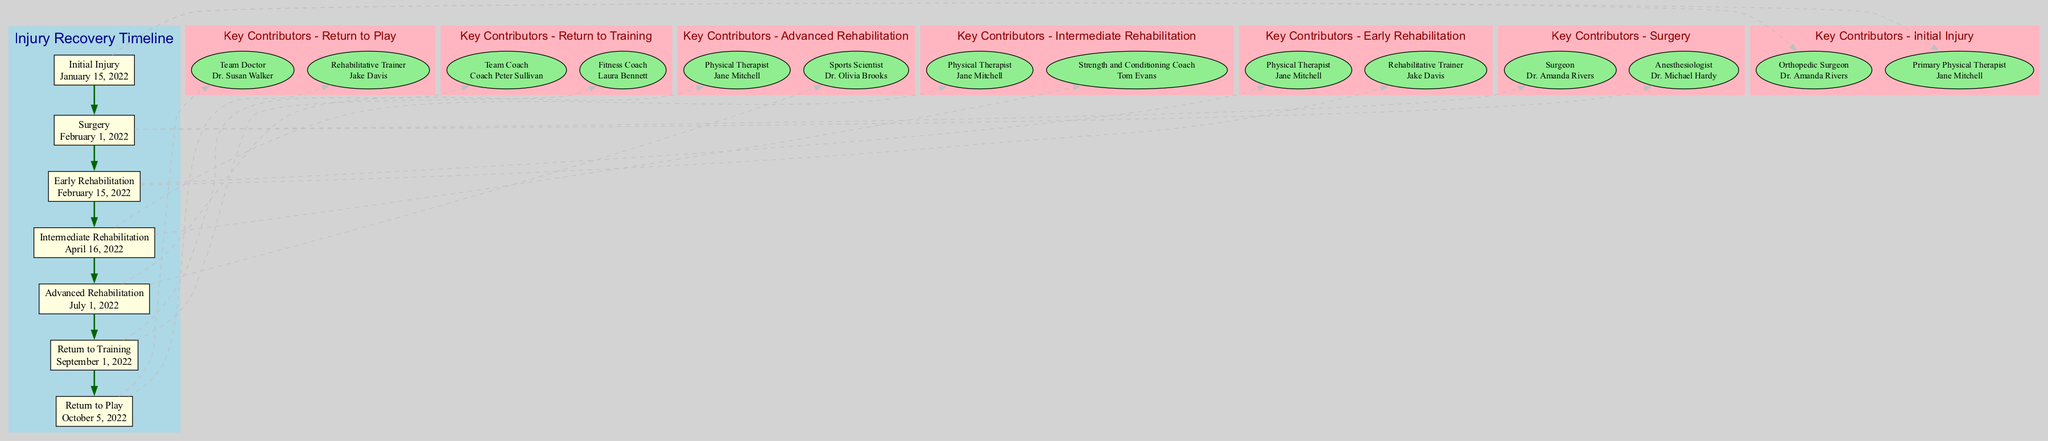What is the date of the Initial Injury? The diagram states the date of the Initial Injury as "January 15, 2022." This information is found directly in the section labeled "Initial Injury."
Answer: January 15, 2022 Who was the surgeon during the Surgery? The diagram indicates that "Dr. Amanda Rivers" is the surgeon listed under the "Surgery" stage. This is obtained from the "Key Contributors" section that details the roles and contributors for that stage.
Answer: Dr. Amanda Rivers How long did the Intermediate Rehabilitation last? The duration of the Intermediate Rehabilitation can be calculated by looking at the "Start Date" of "April 16, 2022" and the "End Date" of "June 30, 2022." Counting the days between these two dates confirms the length, which is 75 days.
Answer: 75 days Which contributor is associated with Advanced Rehabilitation? The "Advanced Rehabilitation" section lists "Jane Mitchell" under "Key Contributors" as the Physical Therapist. By consulting the relevant stage, we derive this association.
Answer: Jane Mitchell What type of exercise was emphasized during Advanced Rehabilitation? "Sport-specific drills and full weight-bearing exercises" are mentioned in the details of the "Advanced Rehabilitation" stage, indicating the focus during this phase. This detail is explicitly stated in that segment of the diagram.
Answer: Sport-specific drills and full weight-bearing exercises Which stage comes after Early Rehabilitation? The subsequent stage following "Early Rehabilitation" is "Intermediate Rehabilitation." By observing the flow of the diagram from one stage to the next, we can clearly see the order of stages.
Answer: Intermediate Rehabilitation What role did Coach Peter Sullivan play in the recovery timeline? Coach Peter Sullivan served as the "Team Coach" during the "Return to Training" stage, as noted in the "Key Contributors" for that phase in the diagram. This detail helps identify his involvement in the recovery process.
Answer: Team Coach What date did the Return to Play occur? The diagram specifies that the "Return to Play" took place on "October 5, 2022." This date is directly provided in the section dedicated to this particular event in the recovery timeline.
Answer: October 5, 2022 